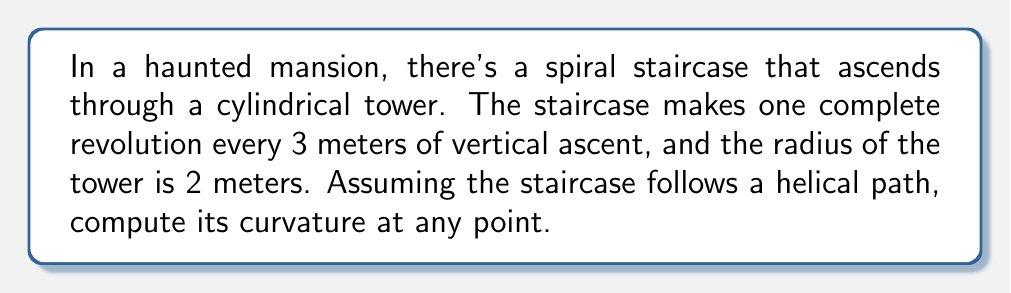Can you answer this question? To solve this problem, we'll follow these steps:

1) First, let's parametrize the helical path of the staircase. If we consider the vertical axis as the z-axis, we can write:

   $$r(t) = (2\cos(t), 2\sin(t), \frac{3t}{2\pi})$$

   where $t$ is the parameter (angle in radians).

2) To find the curvature, we need to calculate $r'(t)$ and $r''(t)$:

   $$r'(t) = (-2\sin(t), 2\cos(t), \frac{3}{2\pi})$$
   $$r''(t) = (-2\cos(t), -2\sin(t), 0)$$

3) The curvature $\kappa$ is given by the formula:

   $$\kappa = \frac{|r'(t) \times r''(t)|}{|r'(t)|^3}$$

4) Let's calculate the cross product $r'(t) \times r''(t)$:

   $$r'(t) \times r''(t) = \begin{vmatrix} 
   i & j & k \\
   -2\sin(t) & 2\cos(t) & \frac{3}{2\pi} \\
   -2\cos(t) & -2\sin(t) & 0
   \end{vmatrix}$$

   $$= (-\frac{3}{\pi}\sin(t), -\frac{3}{\pi}\cos(t), 4)$$

5) The magnitude of this cross product is:

   $$|r'(t) \times r''(t)| = \sqrt{(\frac{3}{\pi})^2(\sin^2(t)+\cos^2(t)) + 16} = \sqrt{\frac{9}{\pi^2} + 16}$$

6) Now, let's calculate $|r'(t)|$:

   $$|r'(t)| = \sqrt{4\sin^2(t) + 4\cos^2(t) + (\frac{3}{2\pi})^2} = \sqrt{4 + (\frac{3}{2\pi})^2}$$

7) Finally, we can compute the curvature:

   $$\kappa = \frac{\sqrt{\frac{9}{\pi^2} + 16}}{(\sqrt{4 + (\frac{3}{2\pi})^2})^3}$$

This expression is constant, meaning the curvature is the same at every point of the spiral staircase.
Answer: $$\kappa = \frac{\sqrt{\frac{9}{\pi^2} + 16}}{(4 + (\frac{3}{2\pi})^2)^{3/2}}$$ 